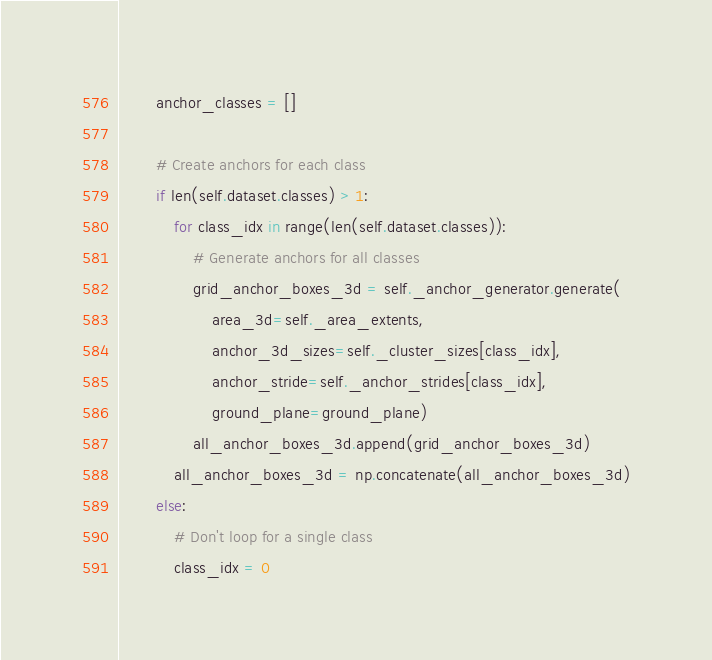Convert code to text. <code><loc_0><loc_0><loc_500><loc_500><_Python_>        anchor_classes = []

        # Create anchors for each class
        if len(self.dataset.classes) > 1:
            for class_idx in range(len(self.dataset.classes)):
                # Generate anchors for all classes
                grid_anchor_boxes_3d = self._anchor_generator.generate(
                    area_3d=self._area_extents,
                    anchor_3d_sizes=self._cluster_sizes[class_idx],
                    anchor_stride=self._anchor_strides[class_idx],
                    ground_plane=ground_plane)
                all_anchor_boxes_3d.append(grid_anchor_boxes_3d)
            all_anchor_boxes_3d = np.concatenate(all_anchor_boxes_3d)
        else:
            # Don't loop for a single class
            class_idx = 0</code> 